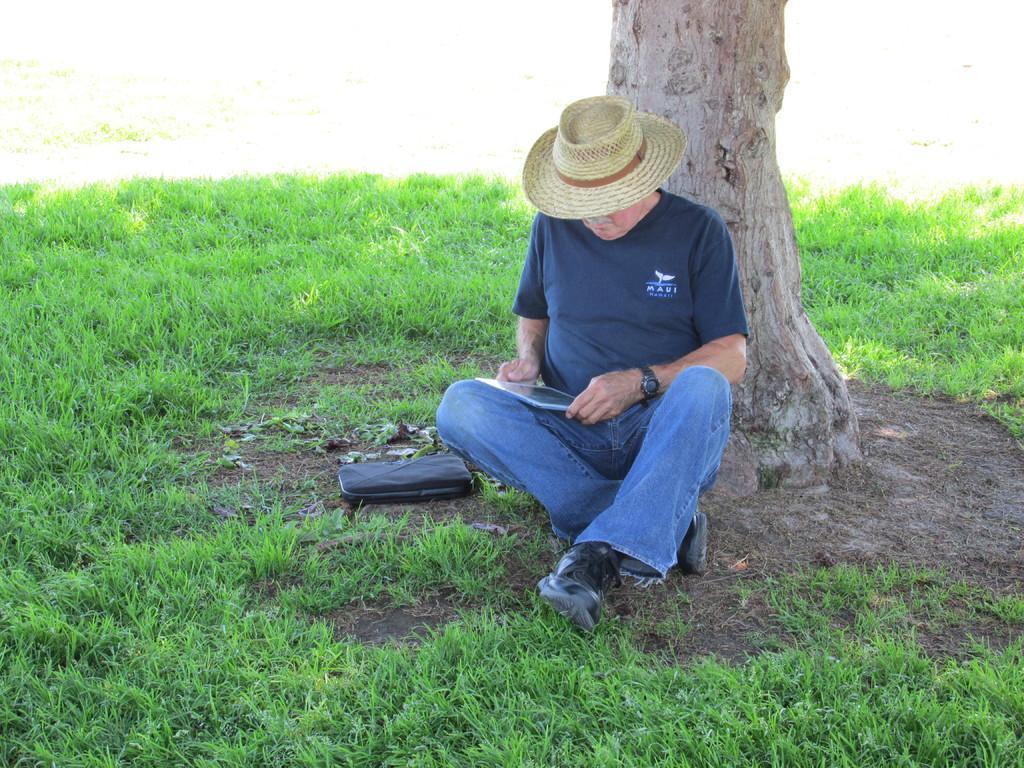Can you describe this image briefly? In this image, we can see a person sitting and holding tab in his hands. In the background, there is a tree and at the bottom, there is ground covered with grass. 